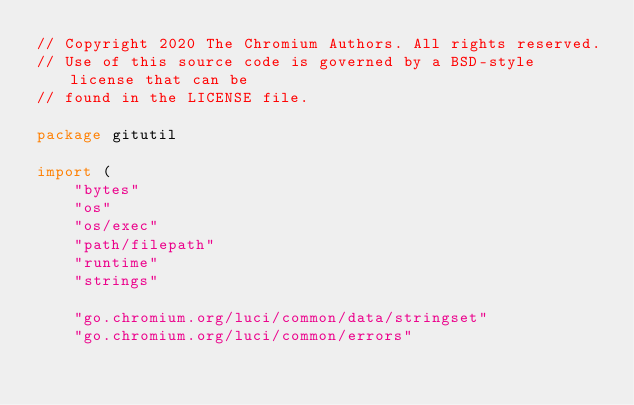<code> <loc_0><loc_0><loc_500><loc_500><_Go_>// Copyright 2020 The Chromium Authors. All rights reserved.
// Use of this source code is governed by a BSD-style license that can be
// found in the LICENSE file.

package gitutil

import (
	"bytes"
	"os"
	"os/exec"
	"path/filepath"
	"runtime"
	"strings"

	"go.chromium.org/luci/common/data/stringset"
	"go.chromium.org/luci/common/errors"</code> 